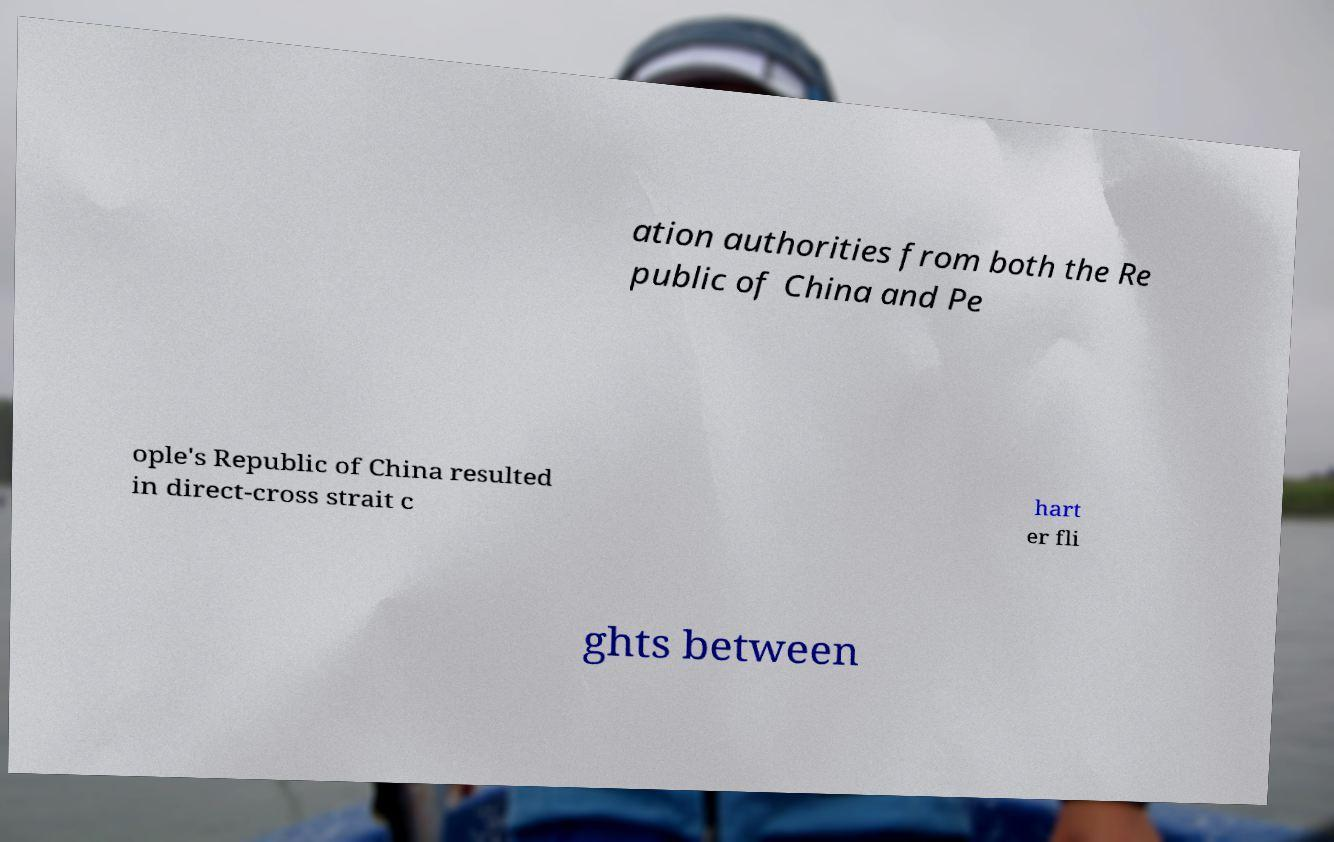Can you read and provide the text displayed in the image?This photo seems to have some interesting text. Can you extract and type it out for me? ation authorities from both the Re public of China and Pe ople's Republic of China resulted in direct-cross strait c hart er fli ghts between 